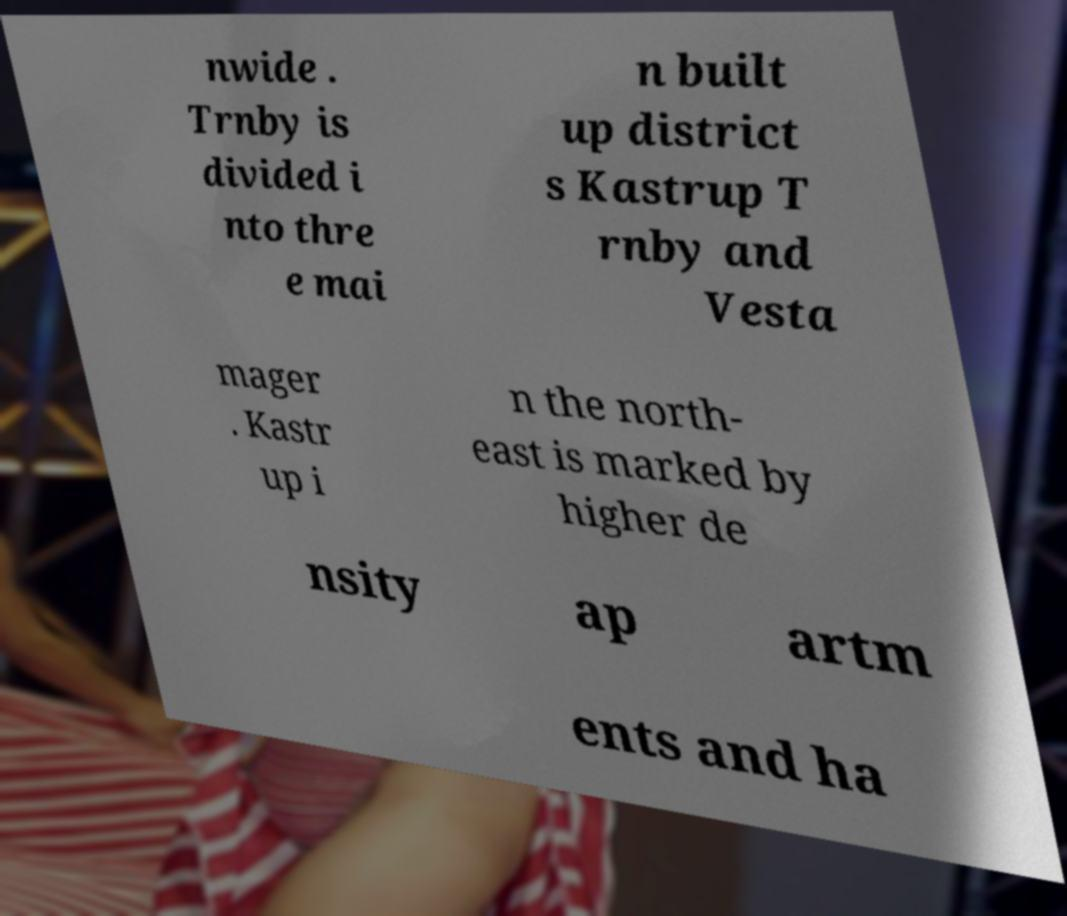There's text embedded in this image that I need extracted. Can you transcribe it verbatim? nwide . Trnby is divided i nto thre e mai n built up district s Kastrup T rnby and Vesta mager . Kastr up i n the north- east is marked by higher de nsity ap artm ents and ha 